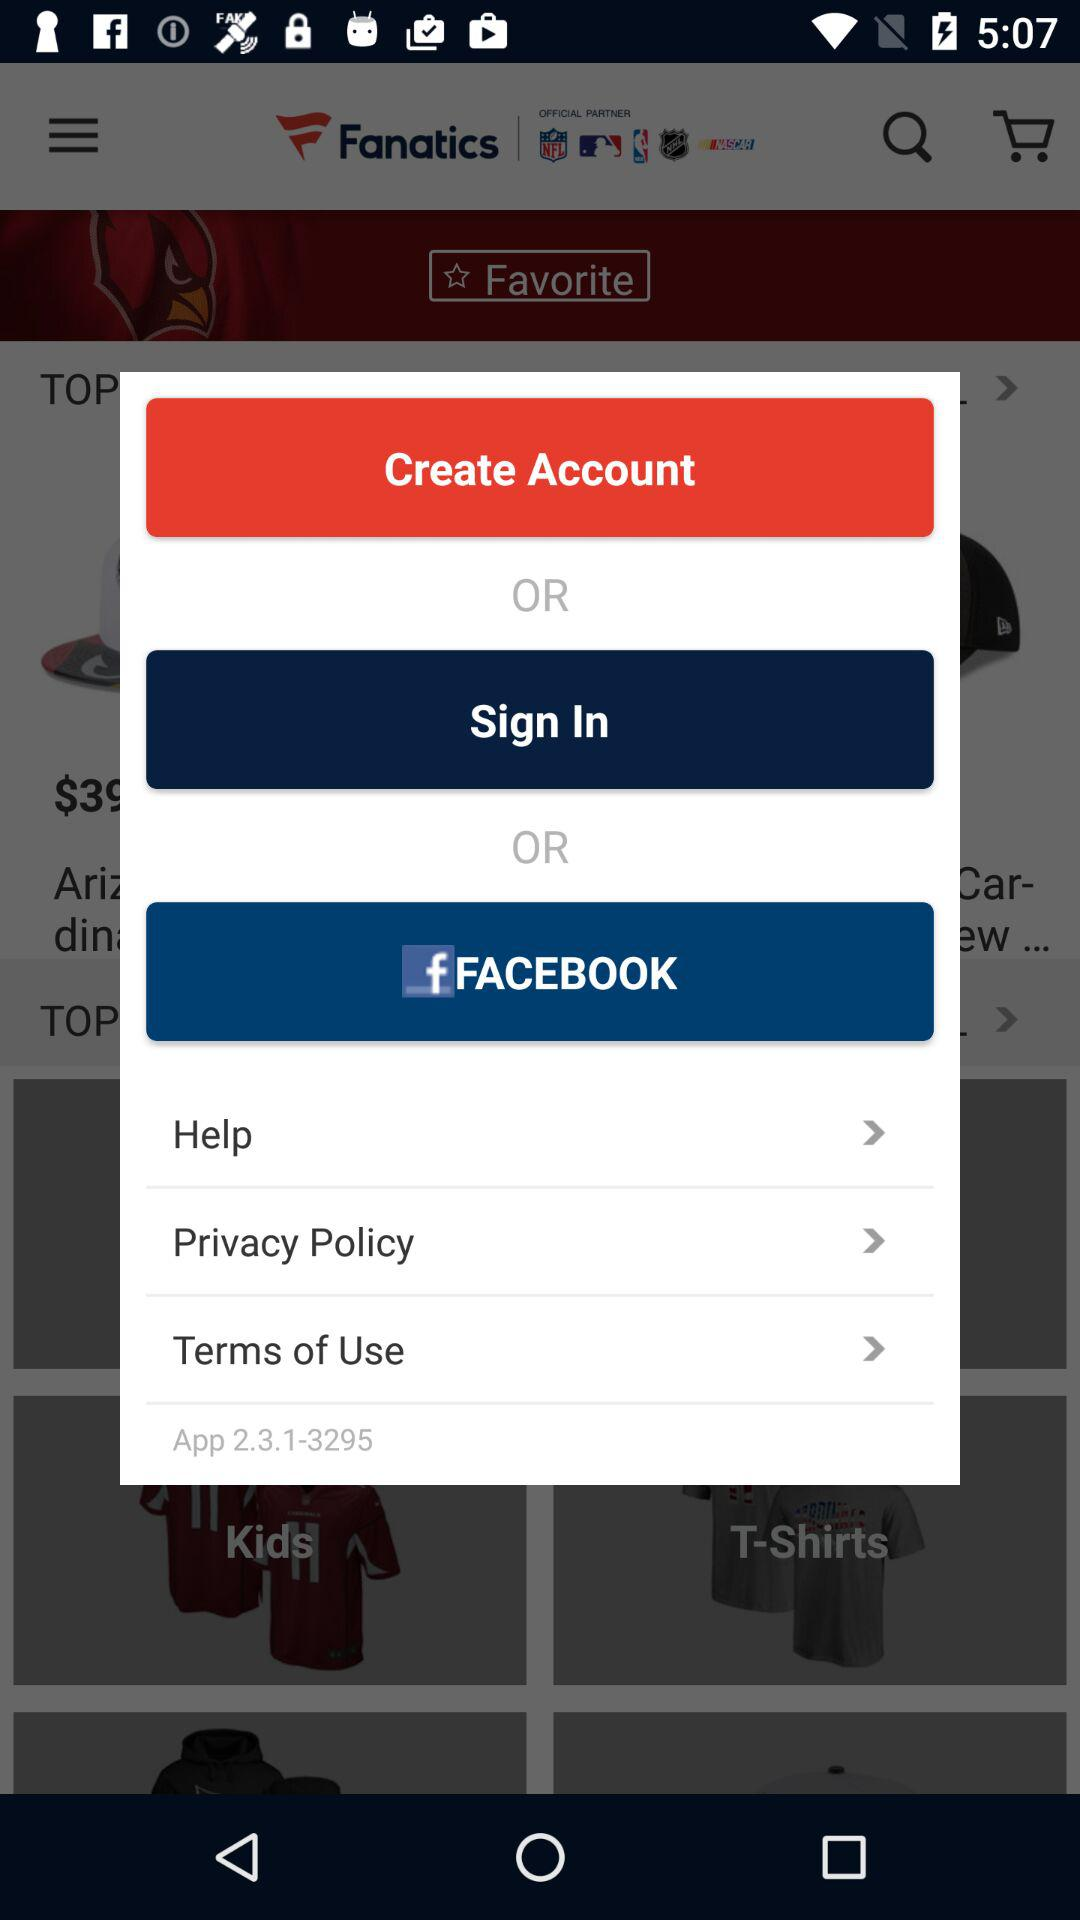What is the app name? The app name is "Fanatics". 